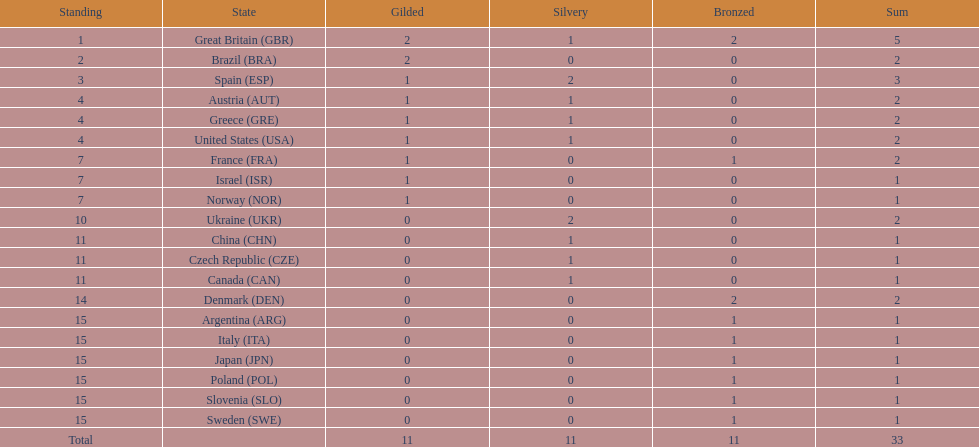In sailing, how many countries achieved at least 2 medals? 9. I'm looking to parse the entire table for insights. Could you assist me with that? {'header': ['Standing', 'State', 'Gilded', 'Silvery', 'Bronzed', 'Sum'], 'rows': [['1', 'Great Britain\xa0(GBR)', '2', '1', '2', '5'], ['2', 'Brazil\xa0(BRA)', '2', '0', '0', '2'], ['3', 'Spain\xa0(ESP)', '1', '2', '0', '3'], ['4', 'Austria\xa0(AUT)', '1', '1', '0', '2'], ['4', 'Greece\xa0(GRE)', '1', '1', '0', '2'], ['4', 'United States\xa0(USA)', '1', '1', '0', '2'], ['7', 'France\xa0(FRA)', '1', '0', '1', '2'], ['7', 'Israel\xa0(ISR)', '1', '0', '0', '1'], ['7', 'Norway\xa0(NOR)', '1', '0', '0', '1'], ['10', 'Ukraine\xa0(UKR)', '0', '2', '0', '2'], ['11', 'China\xa0(CHN)', '0', '1', '0', '1'], ['11', 'Czech Republic\xa0(CZE)', '0', '1', '0', '1'], ['11', 'Canada\xa0(CAN)', '0', '1', '0', '1'], ['14', 'Denmark\xa0(DEN)', '0', '0', '2', '2'], ['15', 'Argentina\xa0(ARG)', '0', '0', '1', '1'], ['15', 'Italy\xa0(ITA)', '0', '0', '1', '1'], ['15', 'Japan\xa0(JPN)', '0', '0', '1', '1'], ['15', 'Poland\xa0(POL)', '0', '0', '1', '1'], ['15', 'Slovenia\xa0(SLO)', '0', '0', '1', '1'], ['15', 'Sweden\xa0(SWE)', '0', '0', '1', '1'], ['Total', '', '11', '11', '11', '33']]} 